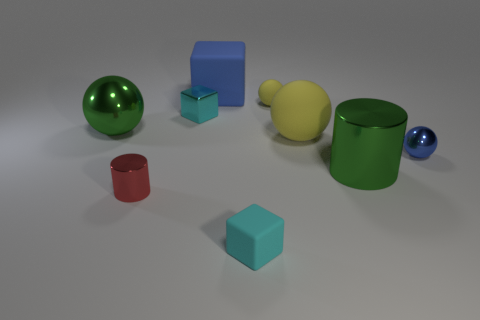There is a small thing that is the same color as the metal cube; what is its material?
Offer a very short reply. Rubber. There is a small rubber object behind the green metal thing behind the metallic cylinder behind the red metal object; what is its shape?
Provide a succinct answer. Sphere. There is a object that is left of the large blue thing and in front of the large shiny sphere; what material is it made of?
Provide a short and direct response. Metal. Does the metallic object that is right of the green metal cylinder have the same size as the small yellow rubber object?
Provide a short and direct response. Yes. Is there anything else that has the same size as the cyan metallic block?
Your answer should be very brief. Yes. Is the number of yellow balls that are in front of the small cyan metallic block greater than the number of big cylinders that are to the right of the blue metal ball?
Keep it short and to the point. Yes. There is a small cube that is in front of the metal cylinder that is on the left side of the large blue object that is on the left side of the tiny blue shiny ball; what color is it?
Ensure brevity in your answer.  Cyan. There is a tiny block on the right side of the large blue matte object; does it have the same color as the small metallic cube?
Make the answer very short. Yes. How many other things are the same color as the tiny rubber block?
Offer a very short reply. 1. What number of objects are tiny matte blocks or metal balls?
Offer a terse response. 3. 